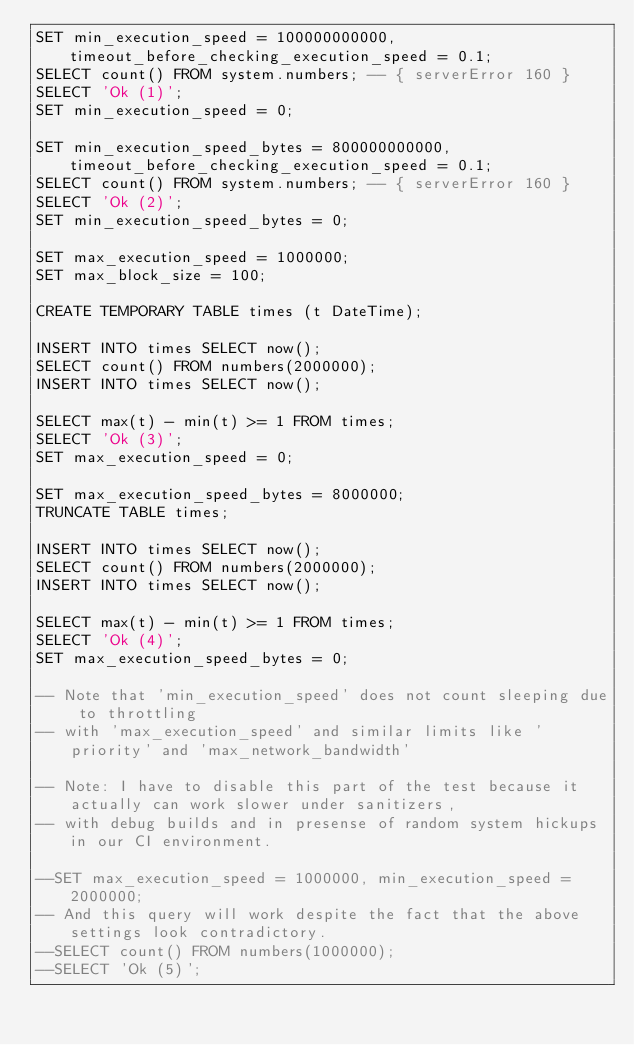Convert code to text. <code><loc_0><loc_0><loc_500><loc_500><_SQL_>SET min_execution_speed = 100000000000, timeout_before_checking_execution_speed = 0.1;
SELECT count() FROM system.numbers; -- { serverError 160 }
SELECT 'Ok (1)';
SET min_execution_speed = 0;

SET min_execution_speed_bytes = 800000000000, timeout_before_checking_execution_speed = 0.1;
SELECT count() FROM system.numbers; -- { serverError 160 }
SELECT 'Ok (2)';
SET min_execution_speed_bytes = 0;

SET max_execution_speed = 1000000;
SET max_block_size = 100;

CREATE TEMPORARY TABLE times (t DateTime);

INSERT INTO times SELECT now();
SELECT count() FROM numbers(2000000);
INSERT INTO times SELECT now();

SELECT max(t) - min(t) >= 1 FROM times;
SELECT 'Ok (3)';
SET max_execution_speed = 0;

SET max_execution_speed_bytes = 8000000;
TRUNCATE TABLE times;

INSERT INTO times SELECT now();
SELECT count() FROM numbers(2000000);
INSERT INTO times SELECT now();

SELECT max(t) - min(t) >= 1 FROM times;
SELECT 'Ok (4)';
SET max_execution_speed_bytes = 0;

-- Note that 'min_execution_speed' does not count sleeping due to throttling
-- with 'max_execution_speed' and similar limits like 'priority' and 'max_network_bandwidth'

-- Note: I have to disable this part of the test because it actually can work slower under sanitizers,
-- with debug builds and in presense of random system hickups in our CI environment.

--SET max_execution_speed = 1000000, min_execution_speed = 2000000;
-- And this query will work despite the fact that the above settings look contradictory.
--SELECT count() FROM numbers(1000000);
--SELECT 'Ok (5)';
</code> 